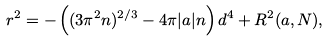<formula> <loc_0><loc_0><loc_500><loc_500>r ^ { 2 } = - \left ( ( 3 \pi ^ { 2 } n ) ^ { 2 / 3 } - 4 \pi | a | n \right ) d ^ { 4 } + R ^ { 2 } ( a , N ) ,</formula> 